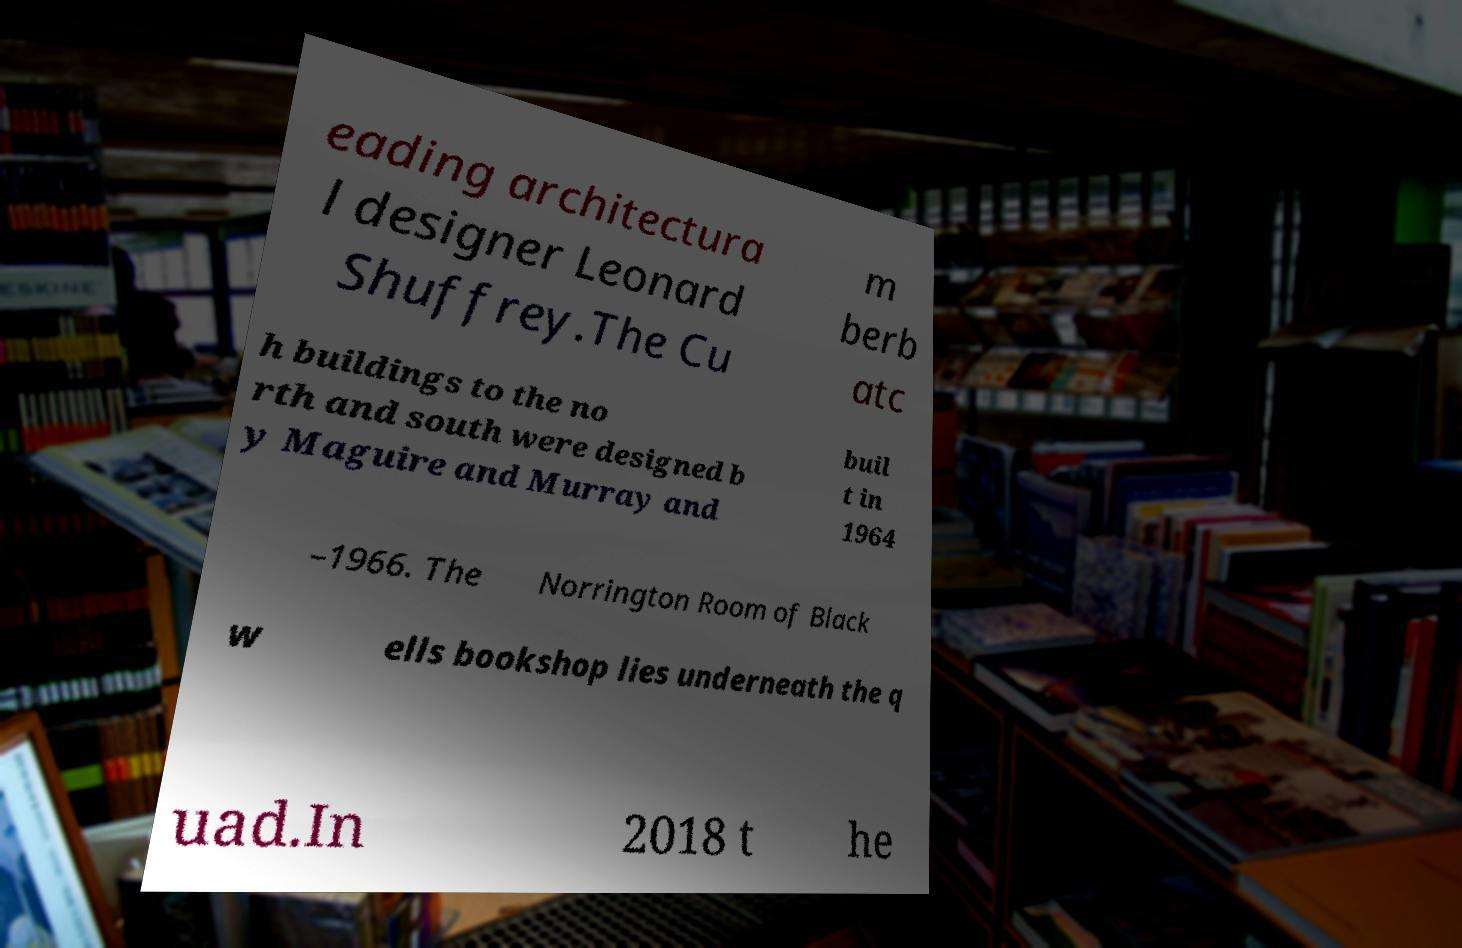Could you extract and type out the text from this image? eading architectura l designer Leonard Shuffrey.The Cu m berb atc h buildings to the no rth and south were designed b y Maguire and Murray and buil t in 1964 –1966. The Norrington Room of Black w ells bookshop lies underneath the q uad.In 2018 t he 